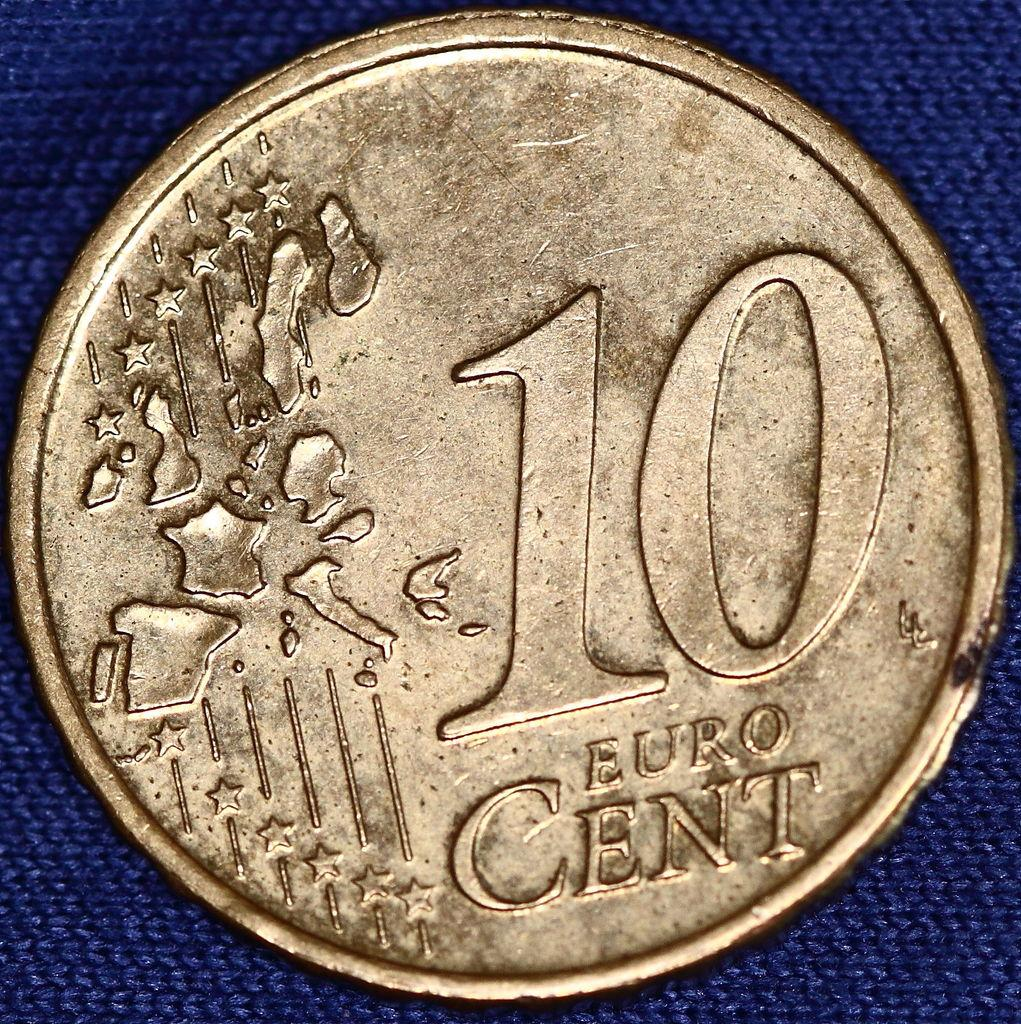Provide a one-sentence caption for the provided image. A gold 10 Euro cent coin with stars and images of european countries on it. 